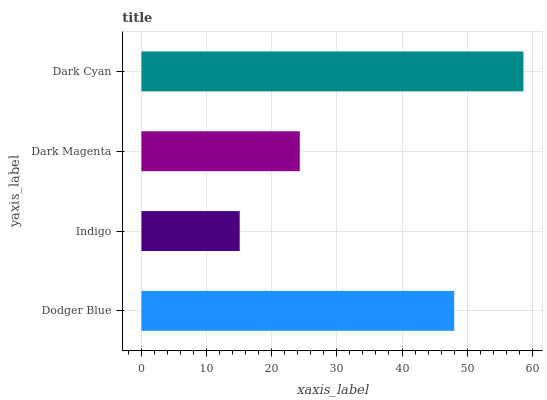Is Indigo the minimum?
Answer yes or no. Yes. Is Dark Cyan the maximum?
Answer yes or no. Yes. Is Dark Magenta the minimum?
Answer yes or no. No. Is Dark Magenta the maximum?
Answer yes or no. No. Is Dark Magenta greater than Indigo?
Answer yes or no. Yes. Is Indigo less than Dark Magenta?
Answer yes or no. Yes. Is Indigo greater than Dark Magenta?
Answer yes or no. No. Is Dark Magenta less than Indigo?
Answer yes or no. No. Is Dodger Blue the high median?
Answer yes or no. Yes. Is Dark Magenta the low median?
Answer yes or no. Yes. Is Indigo the high median?
Answer yes or no. No. Is Dark Cyan the low median?
Answer yes or no. No. 